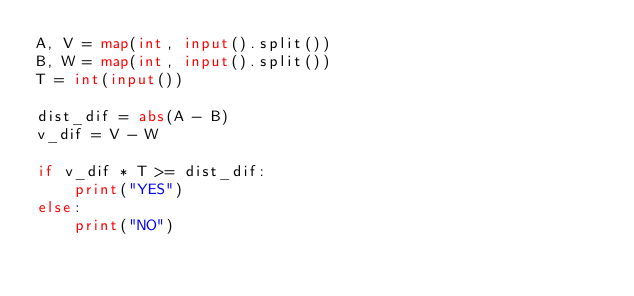Convert code to text. <code><loc_0><loc_0><loc_500><loc_500><_Python_>A, V = map(int, input().split())
B, W = map(int, input().split())
T = int(input())

dist_dif = abs(A - B)
v_dif = V - W

if v_dif * T >= dist_dif:
    print("YES")
else:
    print("NO")</code> 